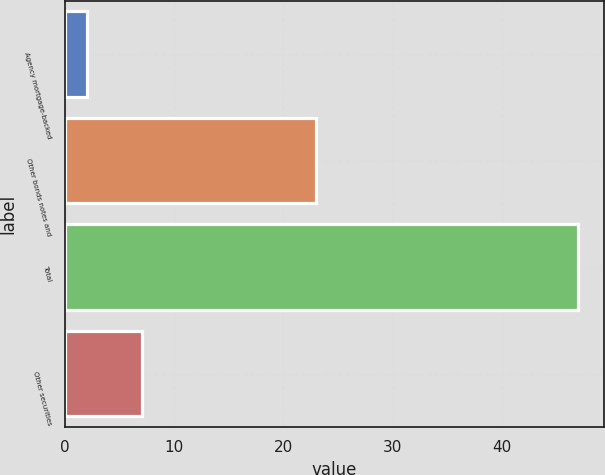Convert chart. <chart><loc_0><loc_0><loc_500><loc_500><bar_chart><fcel>Agency mortgage-backed<fcel>Other bonds notes and<fcel>Total<fcel>Other securities<nl><fcel>2<fcel>23<fcel>47<fcel>7<nl></chart> 